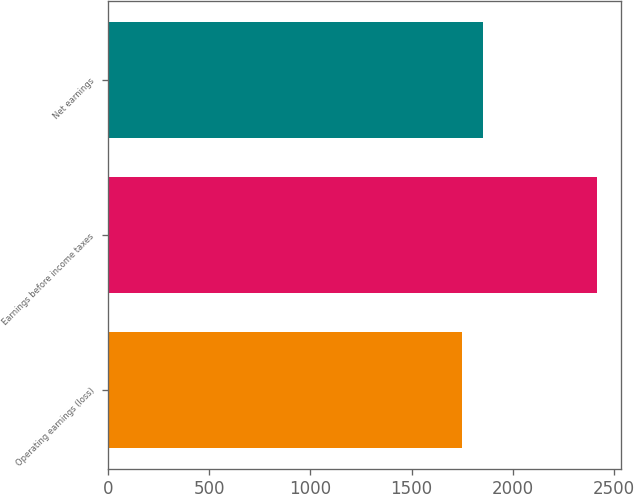<chart> <loc_0><loc_0><loc_500><loc_500><bar_chart><fcel>Operating earnings (loss)<fcel>Earnings before income taxes<fcel>Net earnings<nl><fcel>1746.2<fcel>2413.6<fcel>1851.2<nl></chart> 